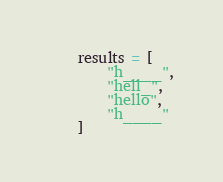<code> <loc_0><loc_0><loc_500><loc_500><_Python_>    results = [
        "h____",
        "hell_",
        "hello",
        "h____"
    ]</code> 